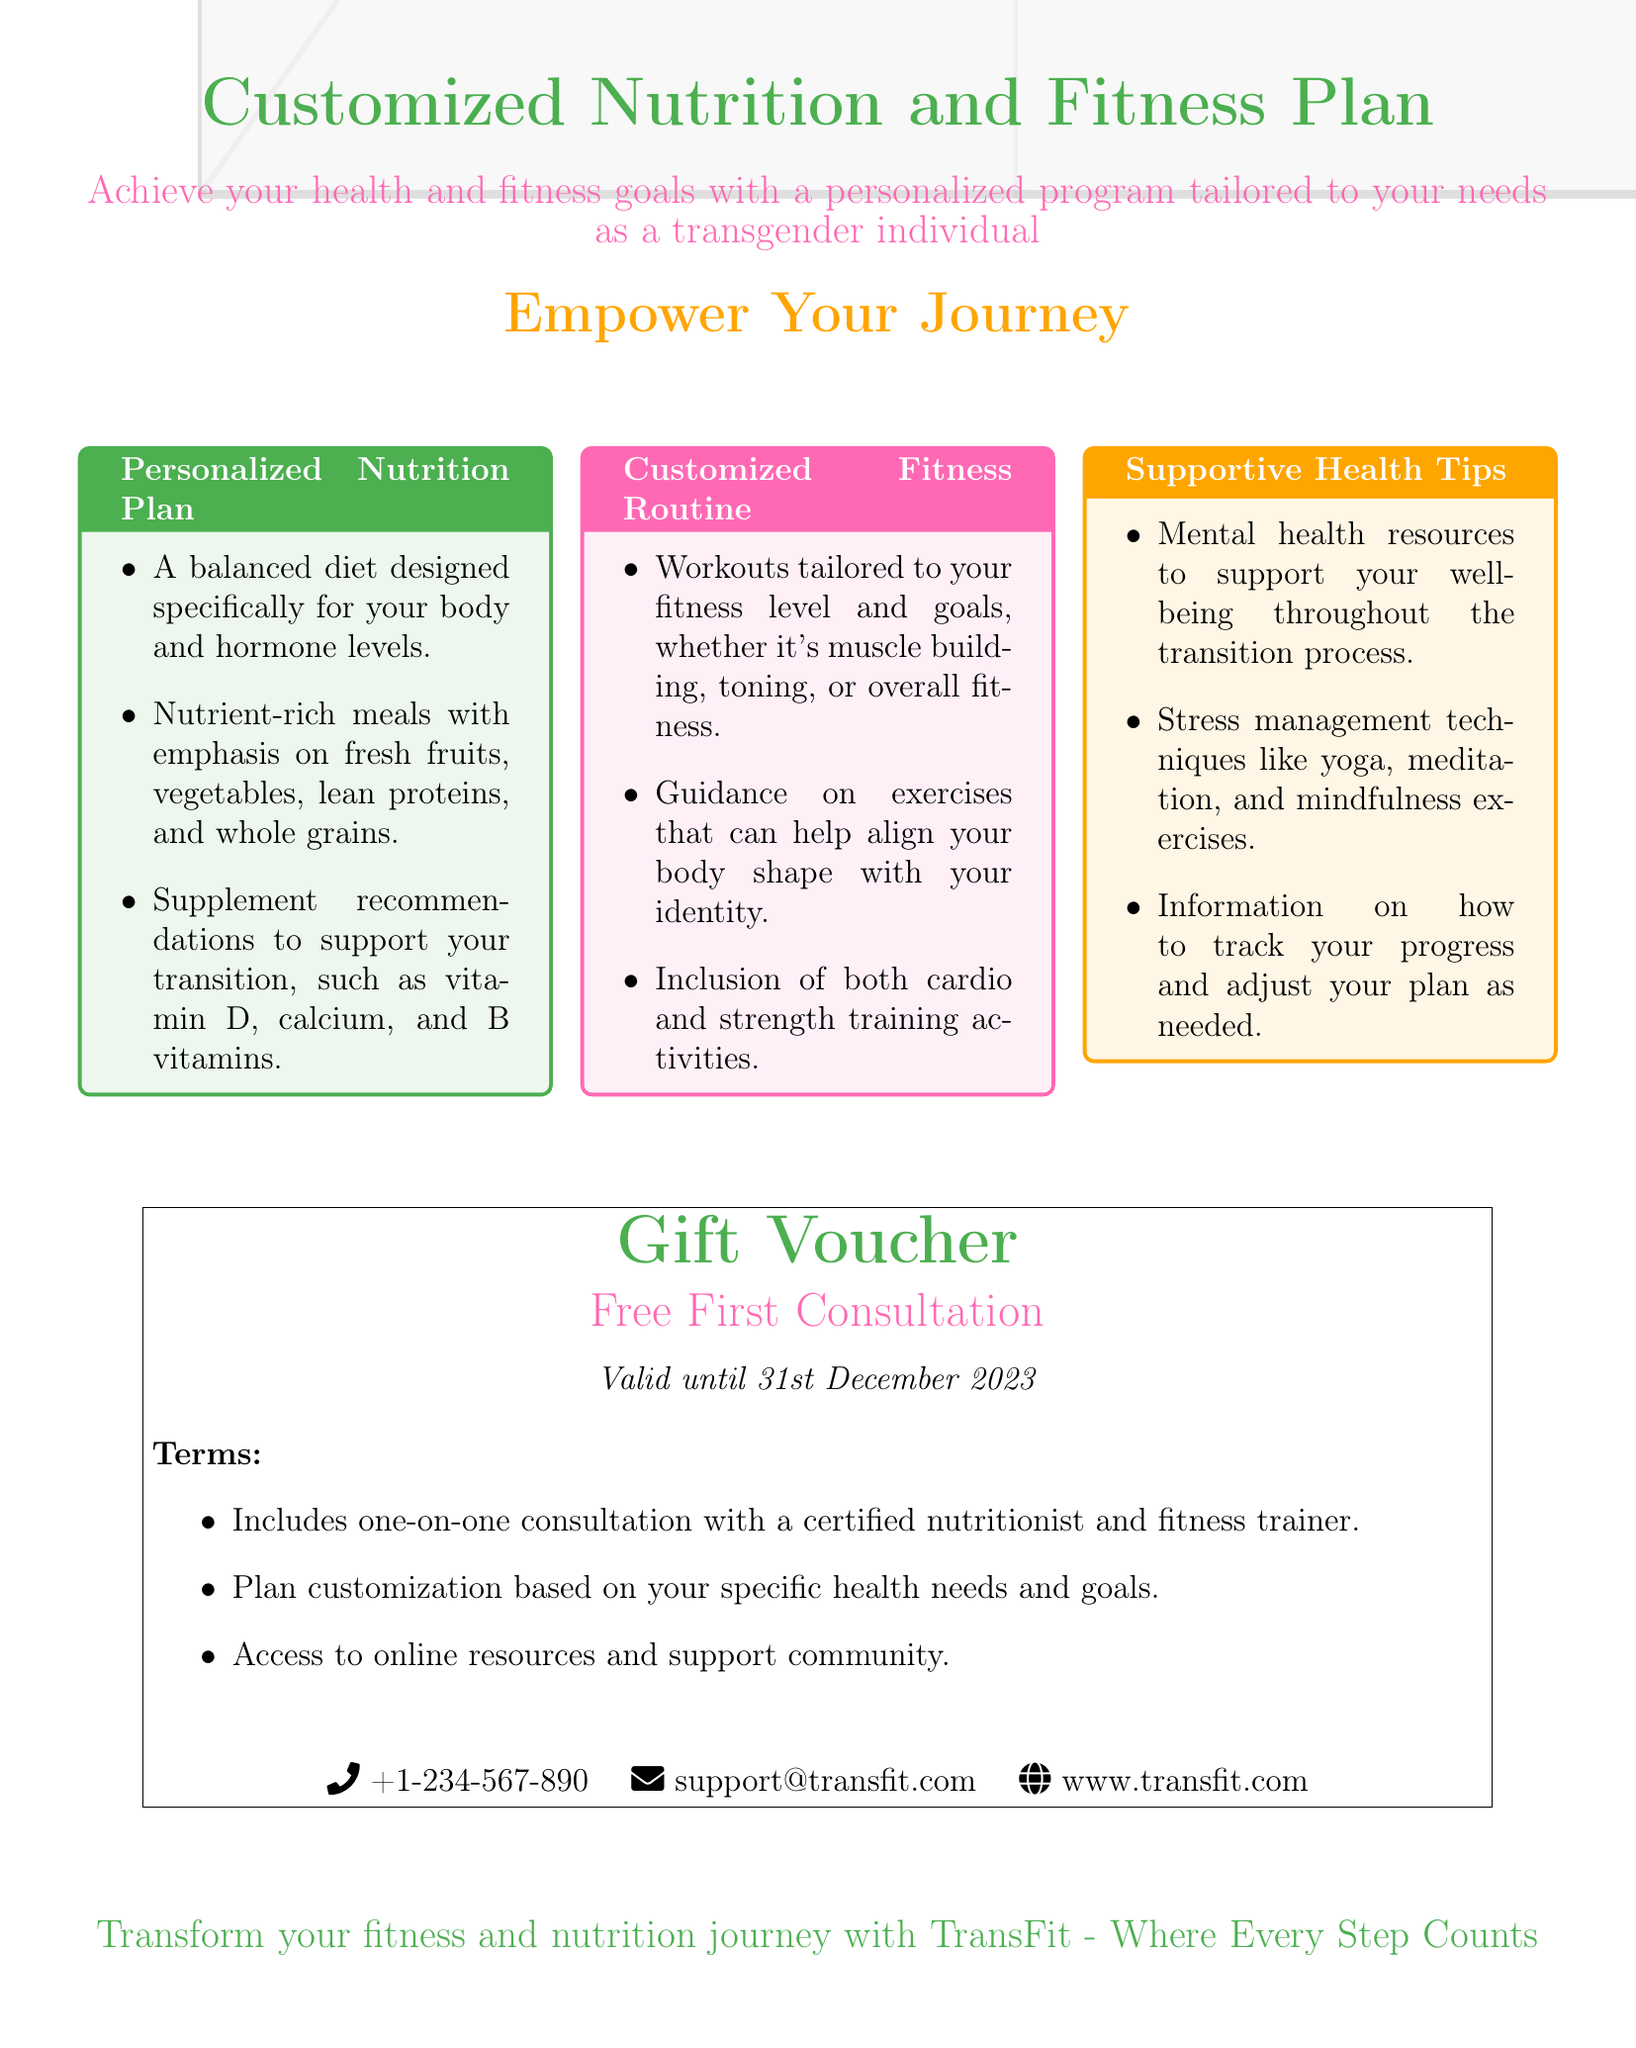what is the title of the document? The title prominently displayed at the top of the document describes the main service offered.
Answer: Customized Nutrition and Fitness Plan what is the theme color of the document? The document specifies various colors, with the main theme color being highlighted throughout.
Answer: 4CAF50 how long is the gift voucher valid? The document mentions a specific date until which the voucher can be redeemed.
Answer: Valid until 31st December 2023 what type of consultation is included in the voucher? The document details the nature of the consultation provided with the voucher.
Answer: one-on-one consultation what type of exercise is included in the customized fitness routine? The fitness routine section of the document specifies the types of activities included.
Answer: cardio and strength training activities what is emphasized in the personalized nutrition plan? The nutrition plan outlines key components that are included for tailored nutrition.
Answer: Nutrient-rich meals how can participants contact for more information? The document provides contact details for further inquiries, highlighting various communication methods.
Answer: +1-234-567-890 what is the focus of the supportive health tips section? The health tips section of the document encompasses different resources aimed at improving well-being.
Answer: Mental health resources what is the primary goal of the document? The overarching aim of the document is described succinctly at the beginning.
Answer: Achieve your health and fitness goals 